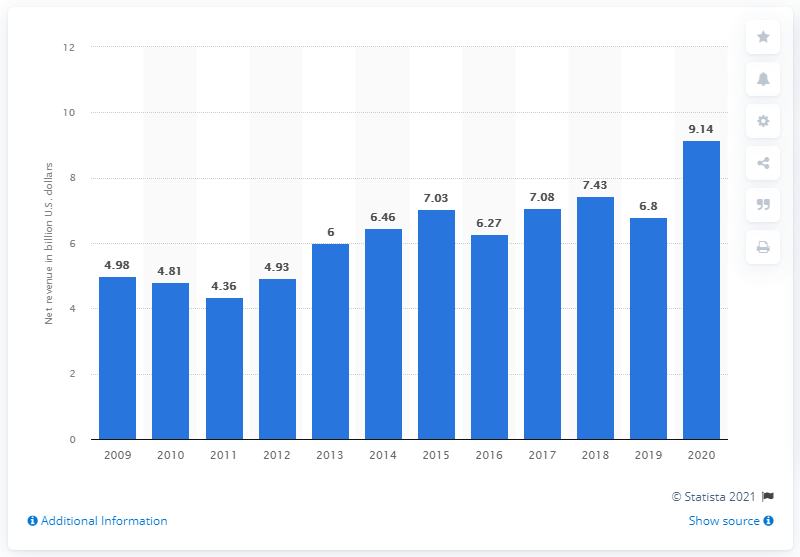Point out several critical features in this image. The net revenue from investment banking at Goldman Sachs in 2020 was approximately 9.14 billion dollars. 